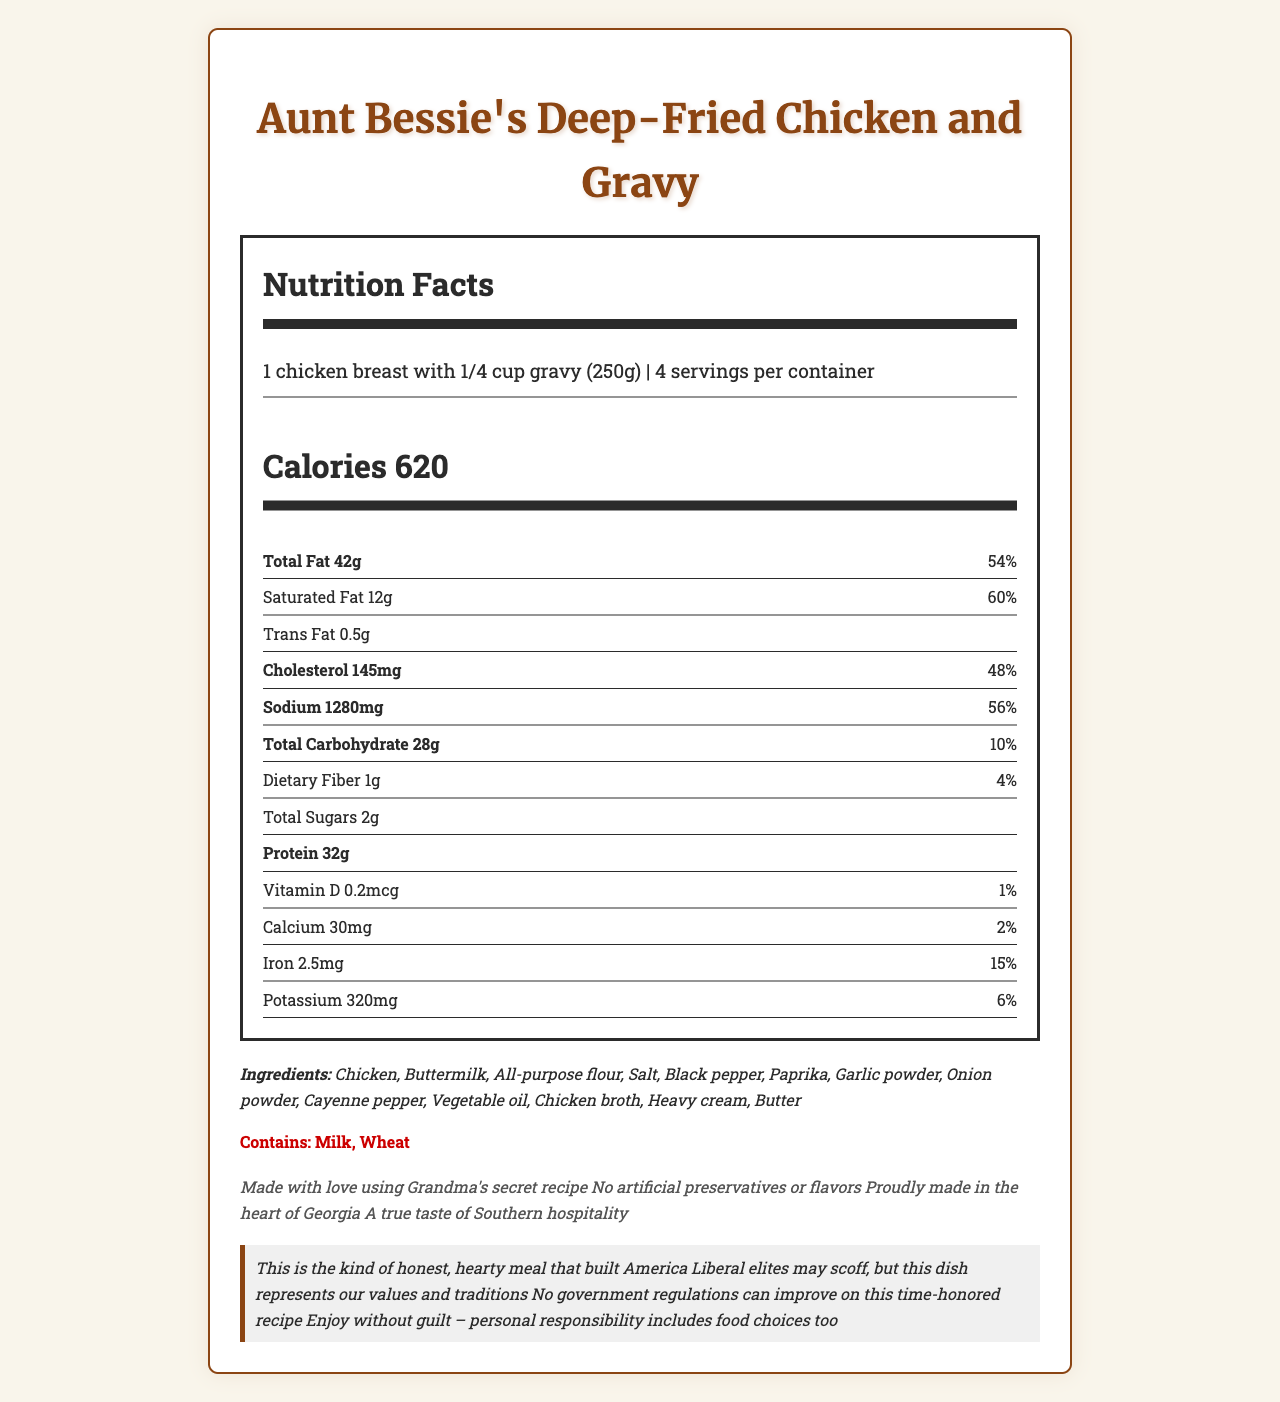what is the serving size? The serving size is outlined at the top of the Nutrition Facts section.
Answer: 1 chicken breast with 1/4 cup gravy (250g) how many calories are in one serving? The calories per serving are listed prominently in the Calorie Info section.
Answer: 620 what is the total fat content per serving? The total fat content is stated in the nutrient information section under Total Fat.
Answer: 42 grams what percentage of the daily value is the sodium content per serving? The percentage daily value for sodium is provided in the nutrient information next to the sodium content.
Answer: 56% how much cholesterol is in a serving? The cholesterol content is listed in the nutrient info section.
Answer: 145 milligrams what is the source of vitamin D in the ingredient list? The list of ingredients does not specify the source of vitamin D.
Answer: Cannot be determined which ingredient is not an allergen? A. Chicken B. Buttermilk C. Black pepper D. All-purpose flour The allergens listed are milk and wheat, which makes black pepper not an allergen.
Answer: C what is the country of origin for Aunt Bessie's Deep-Fried Chicken and Gravy? A. Georgia B. Texas C. Carolina D. Alabama "Proudly made in the heart of Georgia" is mentioned in the additional notes section.
Answer: A is there any trans fat in one serving? The trans fat content is listed as 0.5 grams per serving.
Answer: Yes how many servings are in the container? The total servings per container is indicated at the top of the Nutrition Facts section.
Answer: 4 how many grams of carbohydrates are there per serving? The total carbohydrate content is given in the nutrient information.
Answer: 28 grams can this dish be enjoyed without guilt, according to the conservative commentary? The conservative commentary mentions, "Enjoy without guilt – personal responsibility includes food choices too."
Answer: Yes what are the specific allergens mentioned in the document? The allergens section specifically lists milk and wheat.
Answer: Milk, Wheat how much protein is in a single serving? The protein content for a single serving is stated in the nutrient information.
Answer: 32 grams is there any mention of artificial preservatives or flavors in the dish? The additional notes emphasize, "No artificial preservatives or flavors."
Answer: No summarize the main idea of the document. The document details the nutritional content, ingredients, and additional notes for Aunt Bessie's Deep-Fried Chicken and Gravy, emphasizing its Southern heritage, ingredients, and nutritional profile, while also providing a conservative perspective on enjoying traditional foods.
Answer: Aunt Bessie's Deep-Fried Chicken and Gravy is a traditional Southern comfort food dish made with high-quality ingredients and proudly produced in Georgia. The nutrition label provides detailed information on calories, fats, cholesterol, sodium, carbohydrates, protein, and vitamins. The dish includes allergens like milk and wheat and boasts no artificial preservatives or flavors. The conservative commentary underscores the meal's connection to traditional American values and personal responsibility in food choices. 